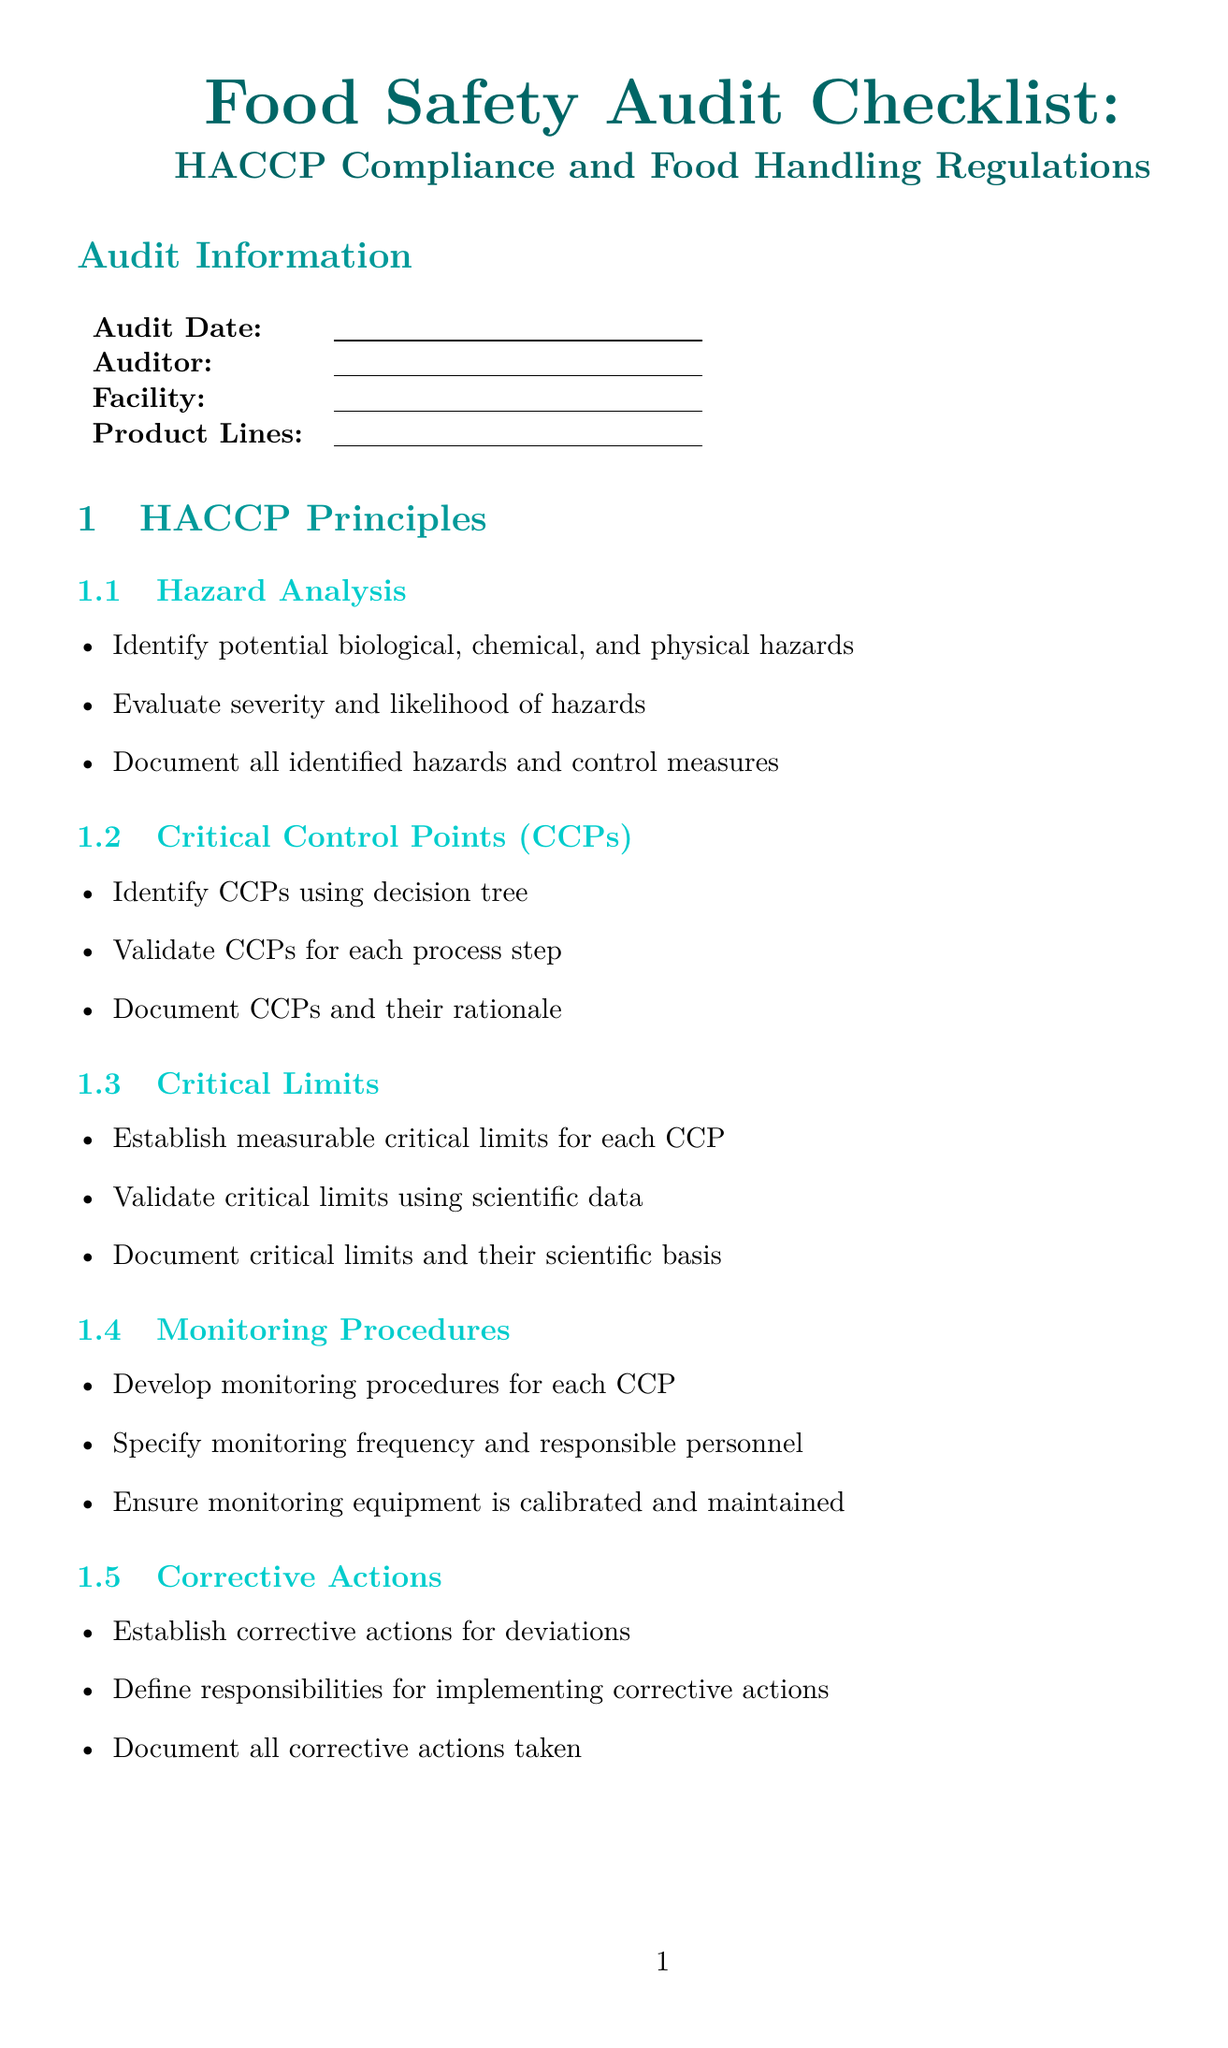What is the title of the document? The title is prominently displayed at the beginning of the document and outlines the subject matter.
Answer: Food Safety Audit Checklist: HACCP Compliance and Food Handling Regulations What temperature should cold storage units maintain? This information can be found under the 'Temperature Control' category in the Food Handling Regulations section.
Answer: Below 4°C (40°F) Which HACCP principle involves establishing measurable limits? This principle focuses on determining the maximum or minimum values to ensure safety during food processing.
Answer: Critical Limits What should be done to assure record-keeping compliance? The document outlines specific requirements that must be followed to maintain proper records.
Answer: Maintain accurate and complete HACCP records What are the pathogen reduction parameters for High Pressure Processing? The document specifies critical elements necessary to validate the processing treatment.
Answer: Pressure, time, temperature What type of control measures are implemented as part of Verification Procedures? This involves methods to ensure that HACCP measures are effective and working as intended.
Answer: Internal audits, testing What is the overall compliance section meant for? This section summarizes the findings of the audit regarding adherence to food safety regulations.
Answer: Overall Compliance How long should records be retained? The document provides guidelines on the required duration for maintaining records.
Answer: Required time period 